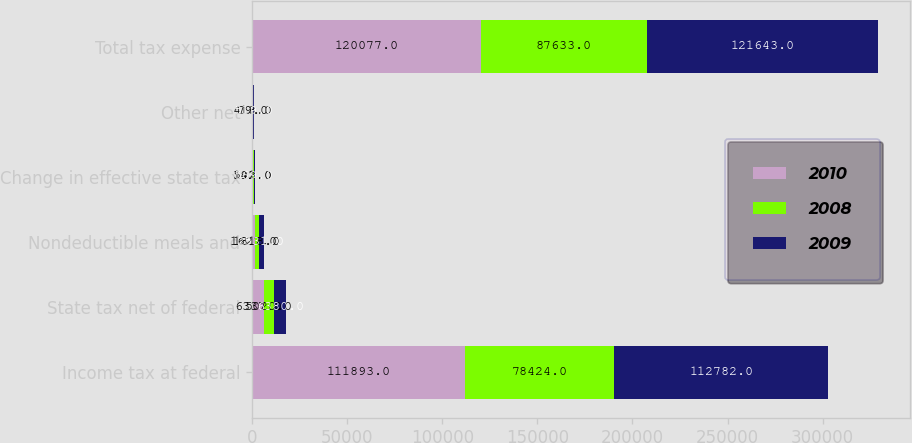<chart> <loc_0><loc_0><loc_500><loc_500><stacked_bar_chart><ecel><fcel>Income tax at federal<fcel>State tax net of federal<fcel>Nondeductible meals and<fcel>Change in effective state tax<fcel>Other net<fcel>Total tax expense<nl><fcel>2010<fcel>111893<fcel>6337<fcel>1627<fcel>141<fcel>79<fcel>120077<nl><fcel>2008<fcel>78424<fcel>5020<fcel>1818<fcel>592<fcel>418<fcel>87633<nl><fcel>2009<fcel>112782<fcel>6380<fcel>2531<fcel>569<fcel>519<fcel>121643<nl></chart> 